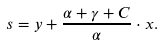<formula> <loc_0><loc_0><loc_500><loc_500>s = y + \frac { \alpha + \gamma + C } { \alpha } \cdot x .</formula> 